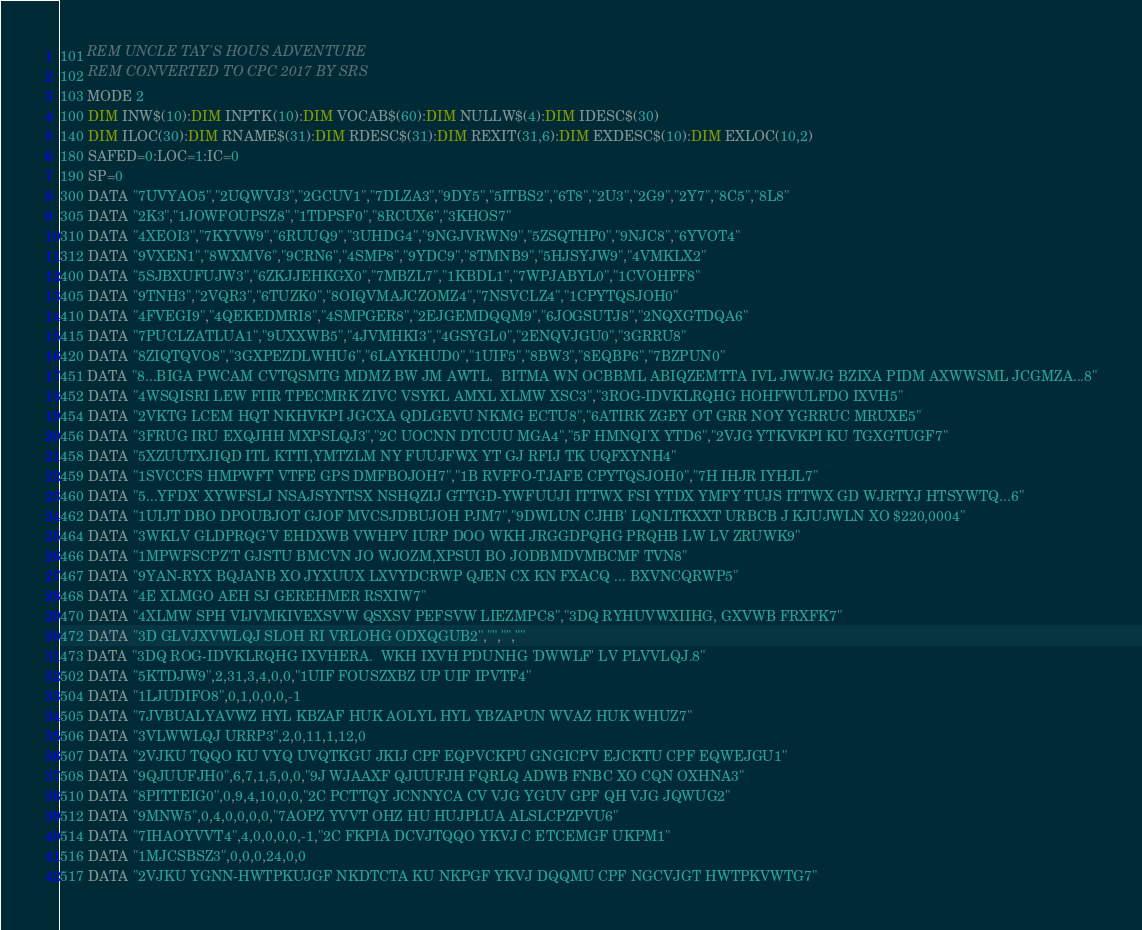Convert code to text. <code><loc_0><loc_0><loc_500><loc_500><_VisualBasic_>101 REM UNCLE TAY'S HOUS ADVENTURE
102 REM CONVERTED TO CPC 2017 BY SRS
103 MODE 2
100 DIM INW$(10):DIM INPTK(10):DIM VOCAB$(60):DIM NULLW$(4):DIM IDESC$(30)
140 DIM ILOC(30):DIM RNAME$(31):DIM RDESC$(31):DIM REXIT(31,6):DIM EXDESC$(10):DIM EXLOC(10,2)
180 SAFED=0:LOC=1:IC=0
190 SP=0 
300 DATA "7UVYAO5","2UQWVJ3","2GCUV1","7DLZA3","9DY5","5ITBS2","6T8","2U3","2G9","2Y7","8C5","8L8"
305 DATA "2K3","1JOWFOUPSZ8","1TDPSF0","8RCUX6","3KHOS7"
310 DATA "4XEOI3","7KYVW9","6RUUQ9","3UHDG4","9NGJVRWN9","5ZSQTHP0","9NJC8","6YVOT4"
312 DATA "9VXEN1","8WXMV6","9CRN6","4SMP8","9YDC9","8TMNB9","5HJSYJW9","4VMKLX2"
400 DATA "5SJBXUFUJW3","6ZKJJEHKGX0","7MBZL7","1KBDL1","7WPJABYL0","1CVOHFF8"
405 DATA "9TNH3","2VQR3","6TUZK0","8OIQVMAJCZOMZ4","7NSVCLZ4","1CPYTQSJOH0"
410 DATA "4FVEGI9","4QEKEDMRI8","4SMPGER8","2EJGEMDQQM9","6JOGSUTJ8","2NQXGTDQA6"
415 DATA "7PUCLZATLUA1","9UXXWB5","4JVMHKI3","4GSYGL0","2ENQVJGU0","3GRRU8"
420 DATA "8ZIQTQVO8","3GXPEZDLWHU6","6LAYKHUD0","1UIF5","8BW3","8EQBP6","7BZPUN0" 
451 DATA "8...BIGA PWCAM CVTQSMTG MDMZ BW JM AWTL.  BITMA WN OCBBML ABIQZEMTTA IVL JWWJG BZIXA PIDM AXWWSML JCGMZA...8"
452 DATA "4WSQISRI LEW FIIR TPECMRK ZIVC VSYKL AMXL XLMW XSC3","3ROG-IDVKLRQHG HOHFWULFDO IXVH5"
454 DATA "2VKTG LCEM HQT NKHVKPI JGCXA QDLGEVU NKMG ECTU8","6ATIRK ZGEY OT GRR NOY YGRRUC MRUXE5"
456 DATA "3FRUG IRU EXQJHH MXPSLQJ3","2C UOCNN DTCUU MGA4","5F HMNQI'X YTD6","2VJG YTKVKPI KU TGXGTUGF7"
458 DATA "5XZUUTXJIQD ITL KTTI,YMTZLM NY FUUJFWX YT GJ RFIJ TK UQFXYNH4"
459 DATA "1SVCCFS HMPWFT VTFE GPS DMFBOJOH7","1B RVFFO-TJAFE CPYTQSJOH0","7H IHJR IYHJL7"
460 DATA "5...YFDX' XYWFSLJ NSAJSYNTSX NSHQZIJ GTTGD-YWFUUJI ITTWX FSI YTDX YMFY TUJS ITTWX GD WJRTYJ HTSYWTQ...6"
462 DATA "1UIJT DBO DPOUBJOT GJOF MVCSJDBUJOH PJM7","9DWLUN CJHB' LQNLTKXXT URBCB J KJUJWLN XO $220,0004"
464 DATA "3WKLV GLDPRQG'V EHDXWB VWHPV IURP DOO WKH JRGGDPQHG PRQHB LW LV ZRUWK9"
466 DATA "1MPWFSCPZ'T GJSTU BMCVN JO WJOZM,XPSUI BO JODBMDVMBCMF TVN8"
467 DATA "9YAN-RYX BQJANB XO JYXUUX LXVYDCRWP QJEN CX KN FXACQ ... BXVNCQRWP5"
468 DATA "4E XLMGO AEH SJ GEREHMER RSXIW7"
470 DATA "4XLMW SPH VIJVMKIVEXSV'W QSXSV PEFSVW LIEZMPC8","3DQ RYHUVWXIIHG, GXVWB FRXFK7"
472 DATA "3D GLVJXVWLQJ SLOH RI VRLOHG ODXQGUB2","","","" 
473 DATA "3DQ ROG-IDVKLRQHG IXVHERA.  WKH IXVH PDUNHG 'DWWLF' LV PLVVLQJ.8"
502 DATA "5KTDJW9",2,31,3,4,0,0,"1UIF FOUSZXBZ UP UIF IPVTF4"
504 DATA "1LJUDIFO8",0,1,0,0,0,-1
505 DATA "7JVBUALYAVWZ HYL KBZAF HUK AOLYL HYL YBZAPUN WVAZ HUK WHUZ7"
506 DATA "3VLWWLQJ URRP3",2,0,11,1,12,0
507 DATA "2VJKU TQQO KU VYQ UVQTKGU JKIJ CPF EQPVCKPU GNGICPV EJCKTU CPF EQWEJGU1"
508 DATA "9QJUUFJH0",6,7,1,5,0,0,"9J WJAAXF QJUUFJH FQRLQ ADWB FNBC XO CQN OXHNA3"
510 DATA "8PITTEIG0",0,9,4,10,0,0,"2C PCTTQY JCNNYCA CV VJG YGUV GPF QH VJG JQWUG2"
512 DATA "9MNW5",0,4,0,0,0,0,"7AOPZ YVVT OHZ HU HUJPLUA ALSLCPZPVU6"
514 DATA "7IHAOYVVT4",4,0,0,0,0,-1,"2C FKPIA DCVJTQQO YKVJ C ETCEMGF UKPM1"
516 DATA "1MJCSBSZ3",0,0,0,24,0,0
517 DATA "2VJKU YGNN-HWTPKUJGF NKDTCTA KU NKPGF YKVJ DQQMU CPF NGCVJGT HWTPKVWTG7"</code> 